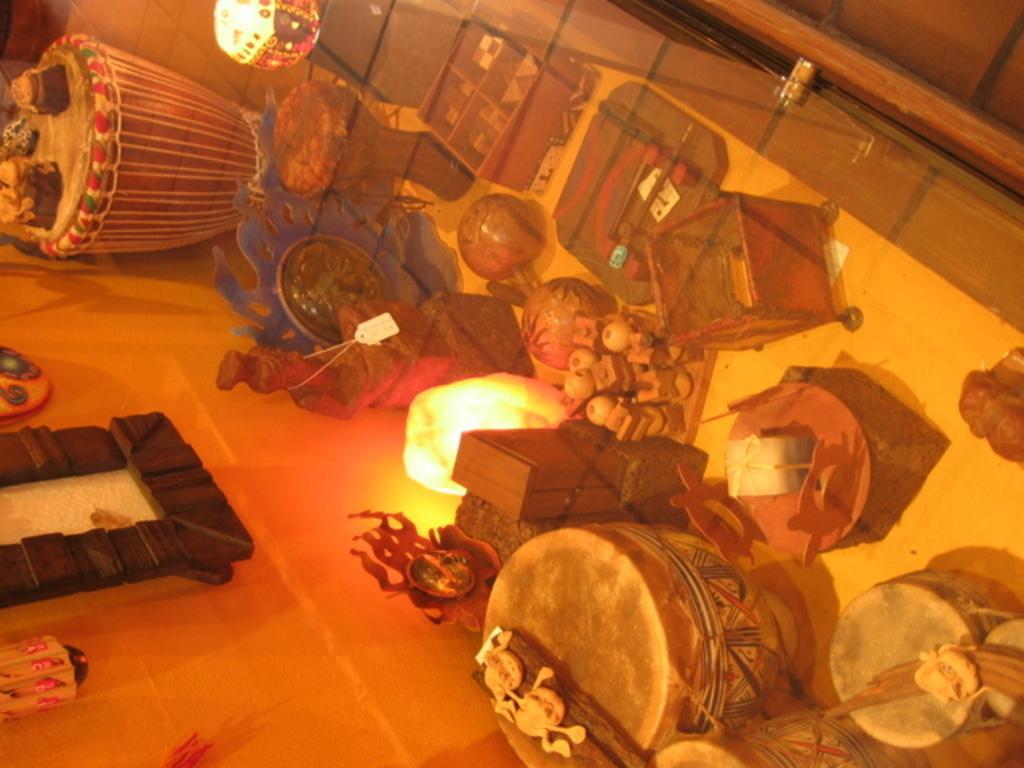Could you give a brief overview of what you see in this image? In this image we can see some musical instruments, lamps, wooden boxes and some objects which are placed on the floor. We can also see a frame on a wall. 